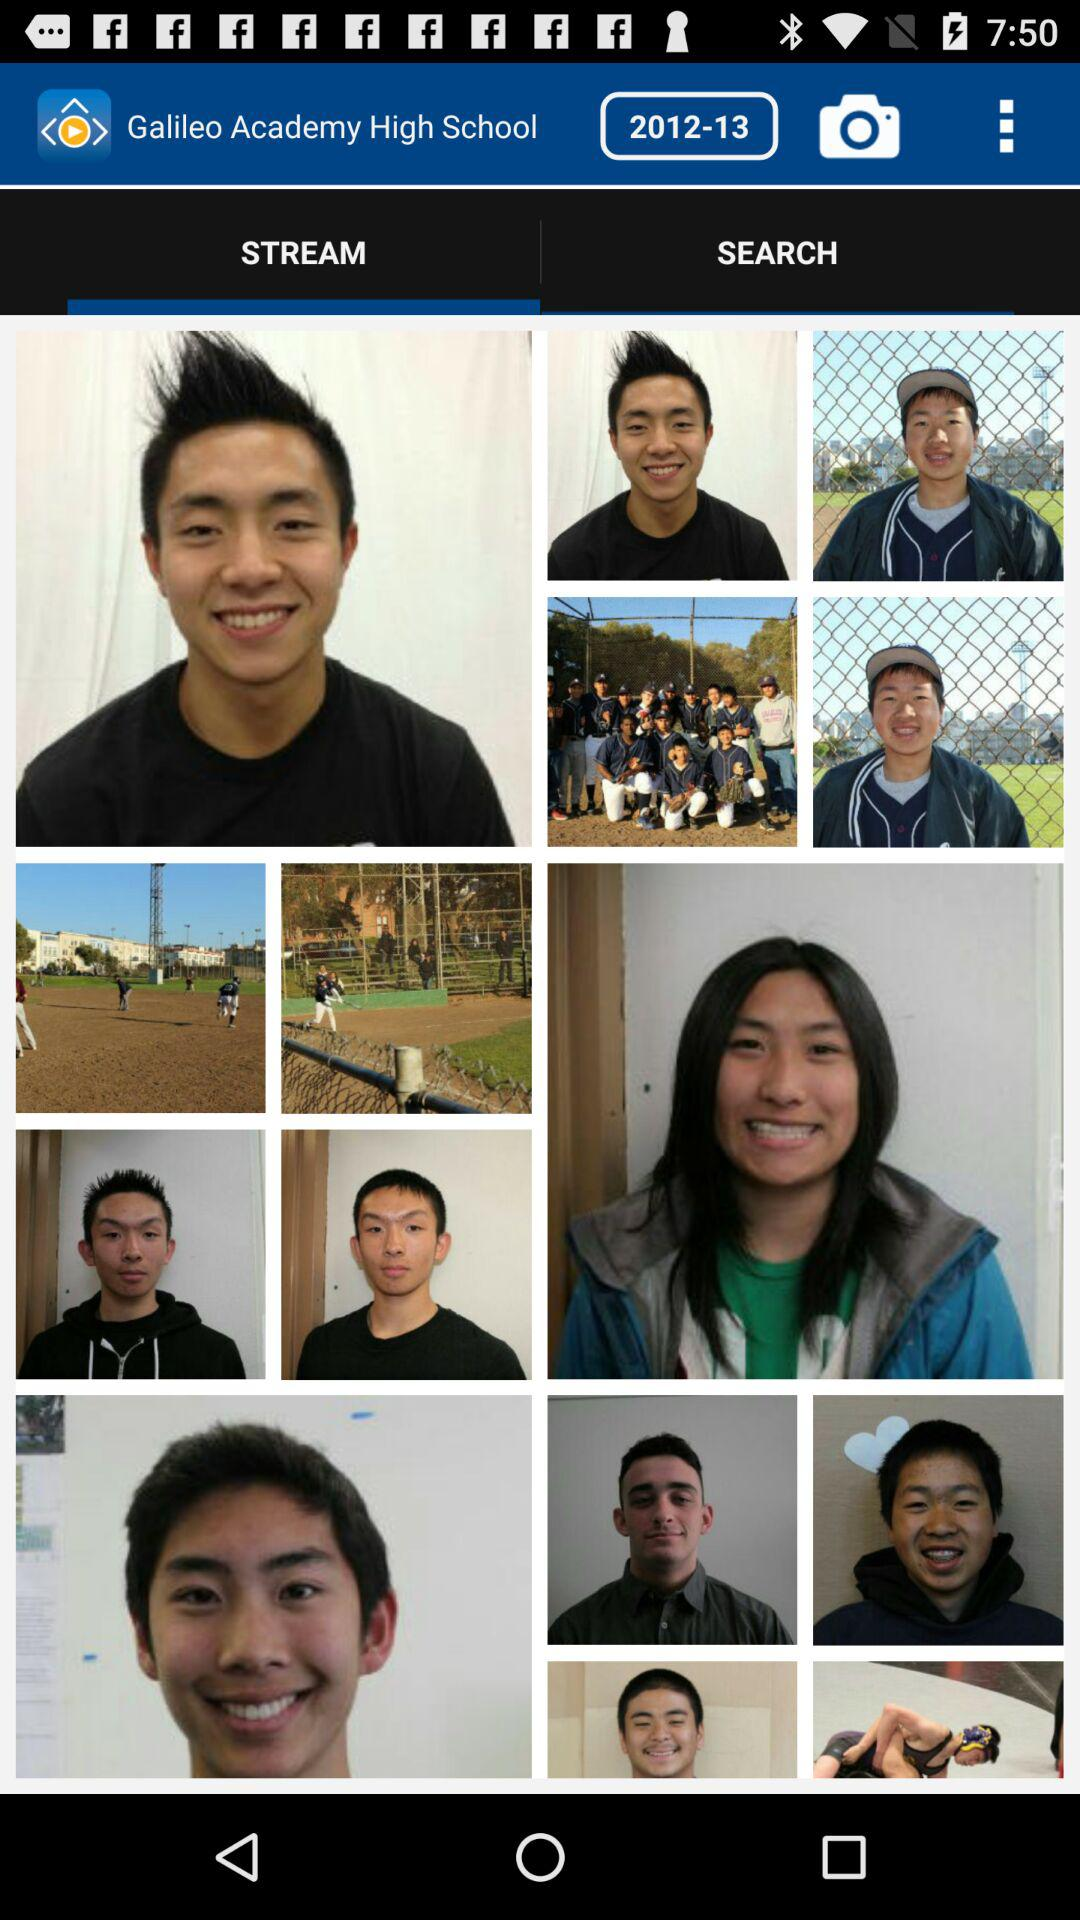What's the streamed year?
When the provided information is insufficient, respond with <no answer>. <no answer> 